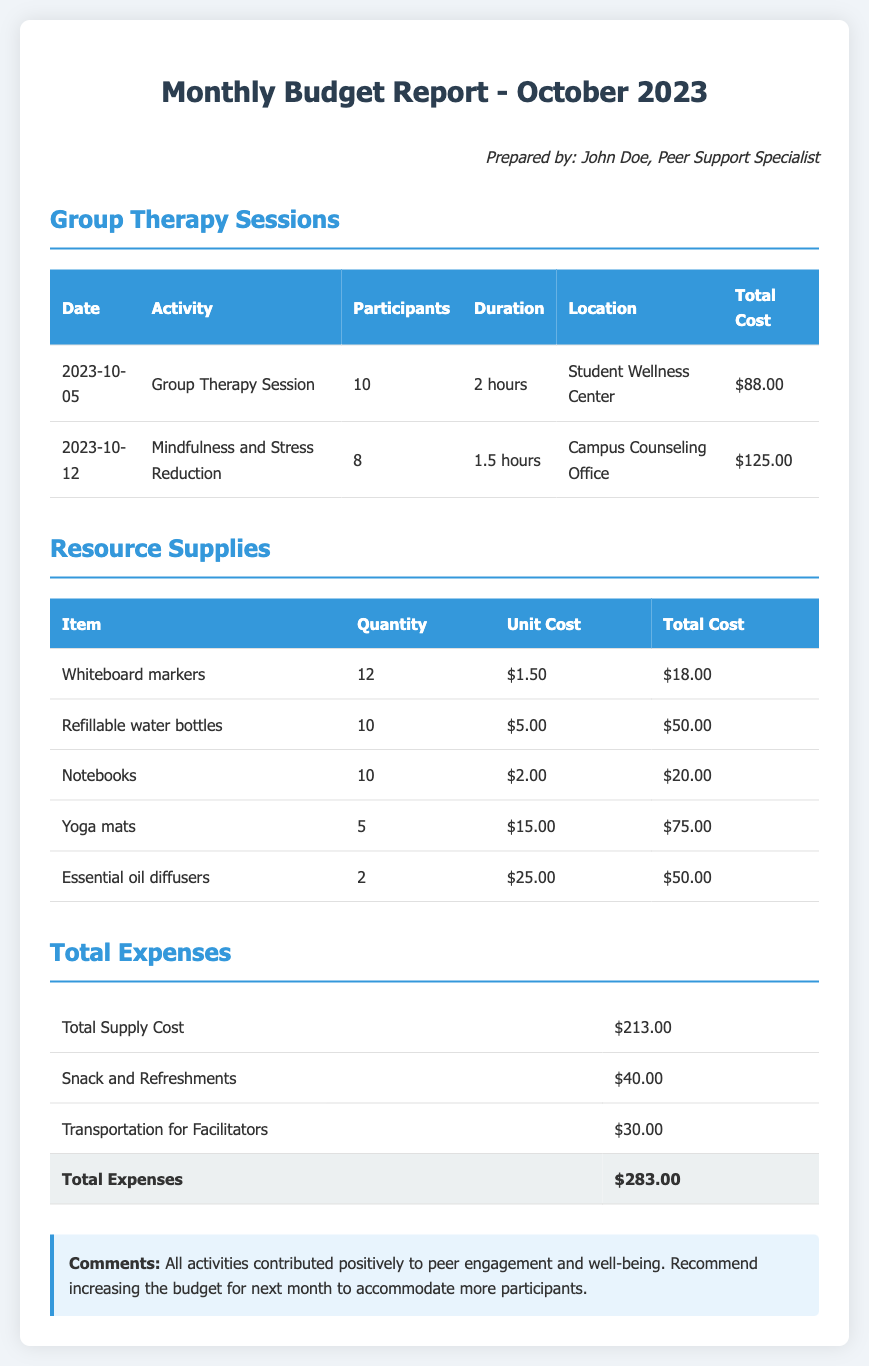What is the total cost of the Group Therapy Session on October 5? The total cost for the Group Therapy Session on October 5 is provided in the table under the Total Cost column.
Answer: $88.00 How many participants attended the Mindfulness and Stress Reduction session? The number of participants for the Mindfulness and Stress Reduction session is indicated in the Participants column of the table.
Answer: 8 What is the total supply cost? The total supply cost is summarized in the Total Expenses section of the document.
Answer: $213.00 Which item had the highest unit cost? To find the item with the highest unit cost, we look at the Unit Cost column and identify the maximum value.
Answer: Yoga mats What's the total amount spent on Snacks and Refreshments? The amount spent on Snacks and Refreshments is detailed in the Total Expenses table.
Answer: $40.00 What date was the Group Therapy Session held? The date of the Group Therapy Session is recorded in the Date column of the table.
Answer: 2023-10-05 What was the duration of the Mindfulness and Stress Reduction activity? The duration for Mindfulness and Stress Reduction is specified in the Duration column of the activities table.
Answer: 1.5 hours What comments were made regarding the activities? Comments about the activities are found in the Comment box at the bottom of the document.
Answer: All activities contributed positively to peer engagement and well-being 